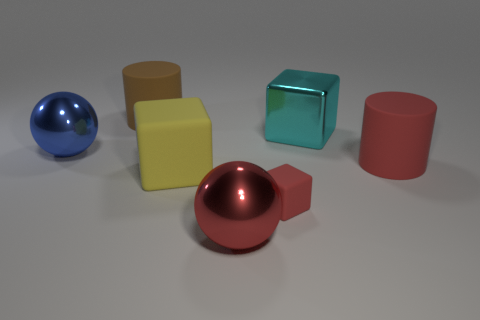Are there any other things that are the same size as the red cube?
Your response must be concise. No. What number of large cylinders are the same color as the tiny cube?
Ensure brevity in your answer.  1. The large metal cube has what color?
Your answer should be compact. Cyan. Do the red shiny ball and the cyan metallic cube have the same size?
Offer a very short reply. Yes. Are there any other things that are the same shape as the big brown object?
Your answer should be very brief. Yes. Are the big cyan object and the cylinder that is in front of the big brown rubber thing made of the same material?
Give a very brief answer. No. There is a large cube that is left of the big cyan object; is it the same color as the big shiny block?
Ensure brevity in your answer.  No. How many large things are left of the red rubber cylinder and in front of the big blue shiny sphere?
Your answer should be very brief. 2. What number of other objects are there of the same material as the yellow cube?
Your answer should be very brief. 3. Is the blue thing left of the small cube made of the same material as the red block?
Ensure brevity in your answer.  No. 